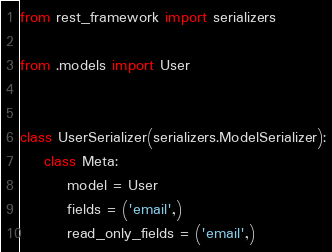Convert code to text. <code><loc_0><loc_0><loc_500><loc_500><_Python_>from rest_framework import serializers

from .models import User


class UserSerializer(serializers.ModelSerializer):
    class Meta:
        model = User
        fields = ('email',)
        read_only_fields = ('email',)
</code> 